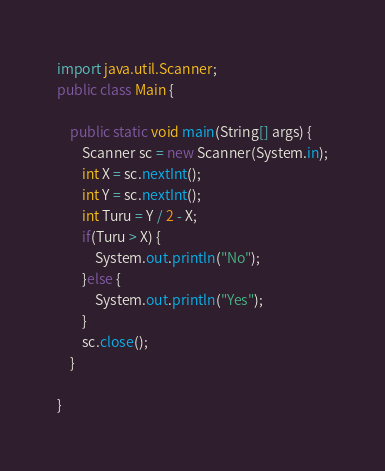<code> <loc_0><loc_0><loc_500><loc_500><_Java_>import java.util.Scanner;
public class Main {

	public static void main(String[] args) {
		Scanner sc = new Scanner(System.in);
		int X = sc.nextInt();
		int Y = sc.nextInt();
		int Turu = Y / 2 - X;
		if(Turu > X) {
			System.out.println("No");
		}else {
			System.out.println("Yes");
		}
		sc.close();
	}

}</code> 